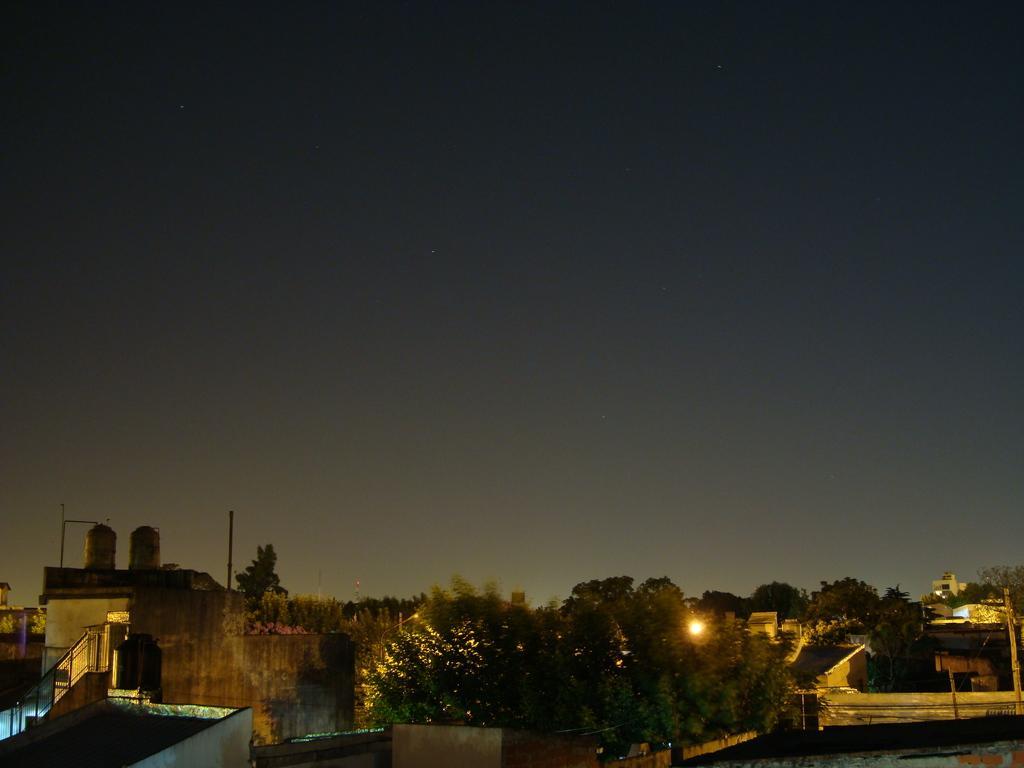How would you summarize this image in a sentence or two? In this picture we can see trees, buildings, water tanks, poles, lights and some objects and in the background we can see the sky. 